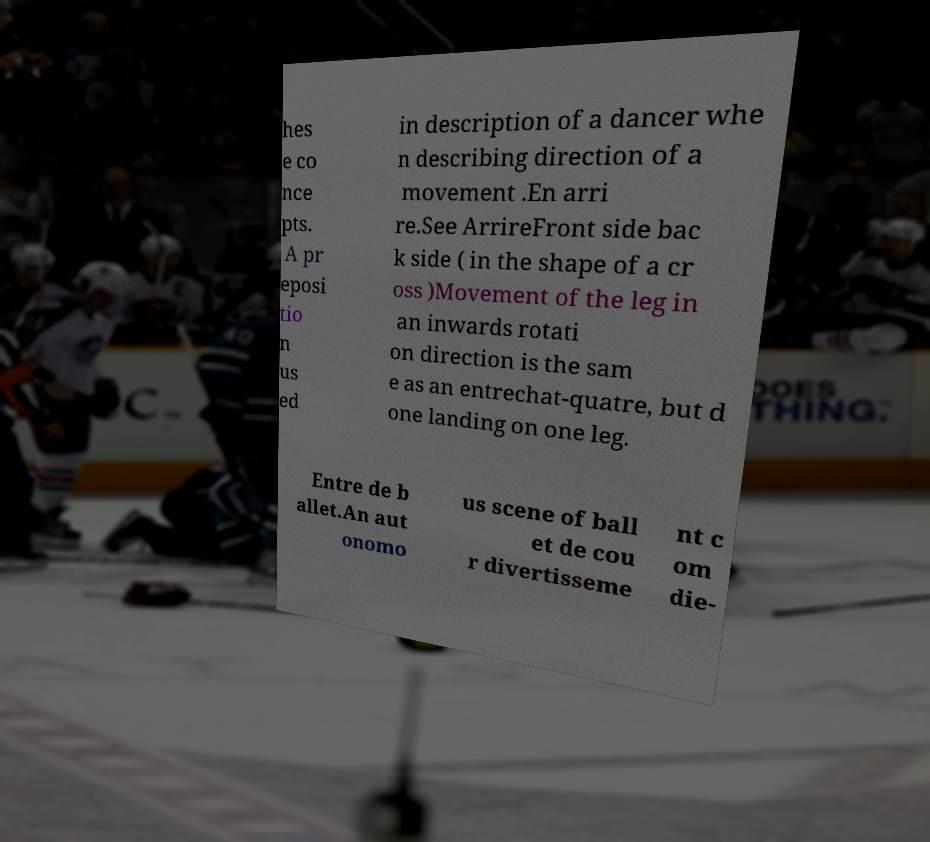Could you assist in decoding the text presented in this image and type it out clearly? hes e co nce pts. A pr eposi tio n us ed in description of a dancer whe n describing direction of a movement .En arri re.See ArrireFront side bac k side ( in the shape of a cr oss )Movement of the leg in an inwards rotati on direction is the sam e as an entrechat-quatre, but d one landing on one leg. Entre de b allet.An aut onomo us scene of ball et de cou r divertisseme nt c om die- 